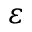<formula> <loc_0><loc_0><loc_500><loc_500>\varepsilon</formula> 